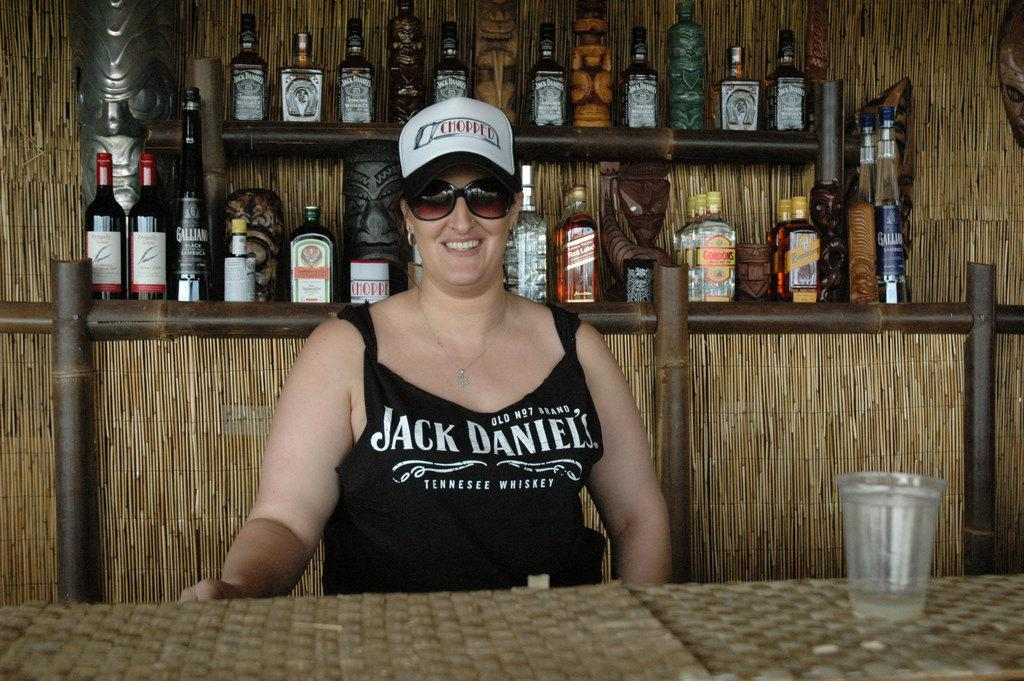Who is the main subject in the image? There is a woman in the image. What is the woman doing in the image? The woman is posing for a camera. What can be seen in the background of the image? There are wine bottles in the background of the image. What type of bikes are being played by the band in the image? There is no band or bikes present in the image; it features a woman posing for a camera with wine bottles in the background. 